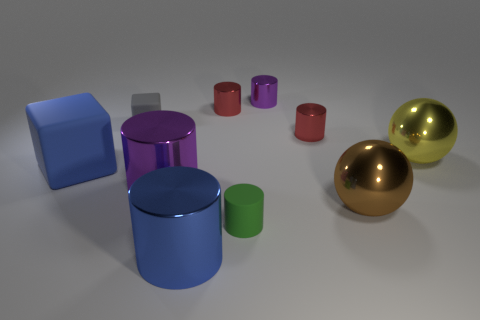What material is the object that is both on the left side of the tiny green cylinder and in front of the brown metal thing?
Make the answer very short. Metal. The matte thing that is both on the left side of the blue metal thing and right of the large cube is what color?
Provide a short and direct response. Gray. Is there anything else that has the same color as the big rubber cube?
Offer a terse response. Yes. The tiny red metallic object that is on the left side of the rubber thing on the right side of the tiny gray matte cube that is behind the blue rubber block is what shape?
Ensure brevity in your answer.  Cylinder. What is the color of the tiny thing that is the same shape as the large rubber object?
Offer a terse response. Gray. There is a large thing in front of the tiny matte thing in front of the large brown shiny thing; what color is it?
Ensure brevity in your answer.  Blue. The other shiny thing that is the same shape as the brown metallic thing is what size?
Offer a terse response. Large. How many big blue blocks have the same material as the tiny gray thing?
Offer a terse response. 1. How many blue metallic cylinders are to the right of the shiny object that is to the left of the big blue cylinder?
Ensure brevity in your answer.  1. Are there any purple things on the left side of the big blue metallic cylinder?
Ensure brevity in your answer.  Yes. 